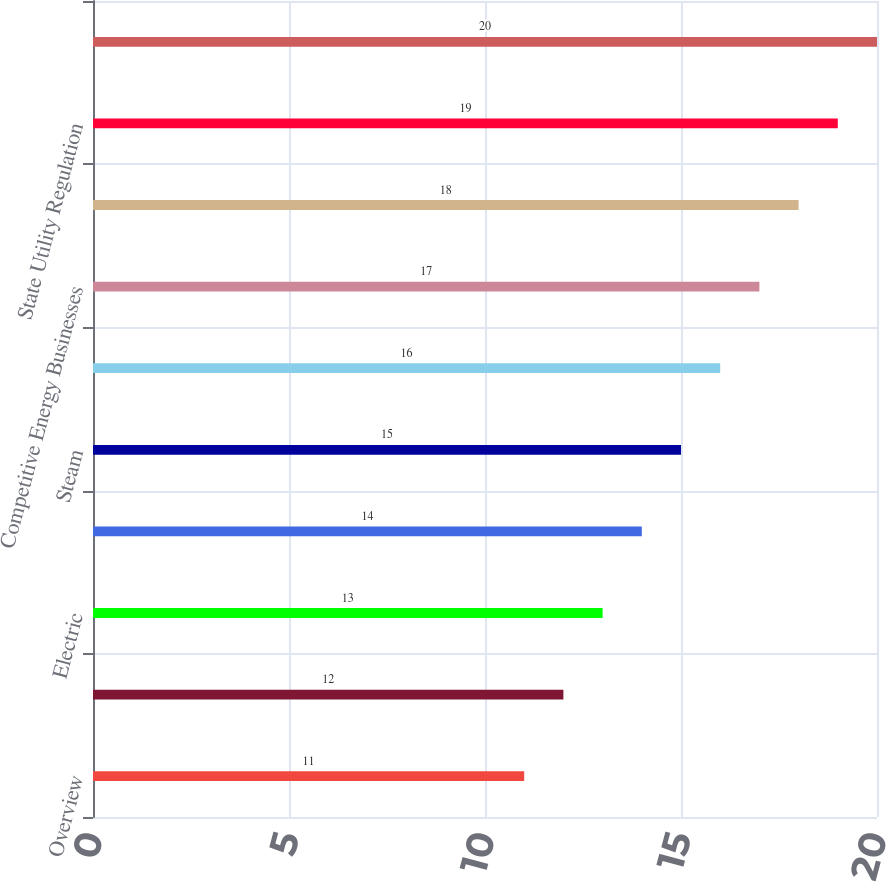<chart> <loc_0><loc_0><loc_500><loc_500><bar_chart><fcel>Overview<fcel>CECONY<fcel>Electric<fcel>Gas<fcel>Steam<fcel>O&R<fcel>Competitive Energy Businesses<fcel>Utility Regulation<fcel>State Utility Regulation<fcel>Regulators<nl><fcel>11<fcel>12<fcel>13<fcel>14<fcel>15<fcel>16<fcel>17<fcel>18<fcel>19<fcel>20<nl></chart> 